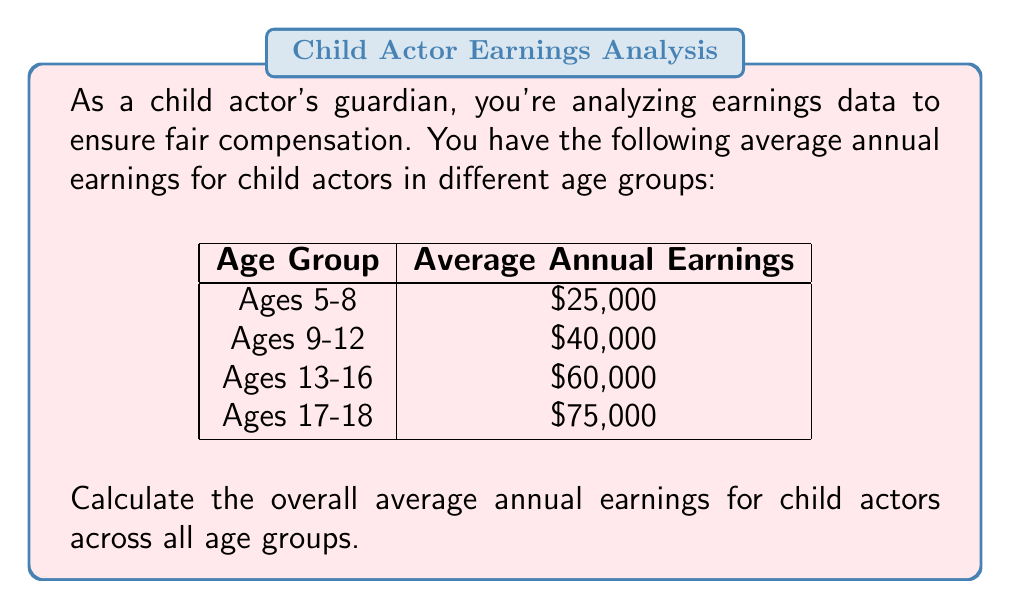Show me your answer to this math problem. To calculate the overall average annual earnings, we need to:

1. Sum up all the average earnings:
   $25,000 + $40,000 + $60,000 + $75,000 = $200,000$

2. Count the number of age groups:
   There are 4 age groups.

3. Divide the sum by the number of age groups:
   $$\text{Overall Average} = \frac{\text{Sum of Averages}}{\text{Number of Age Groups}}$$
   
   $$\text{Overall Average} = \frac{$200,000}{4} = $50,000$$

Therefore, the overall average annual earnings for child actors across all age groups is $50,000.
Answer: $50,000 